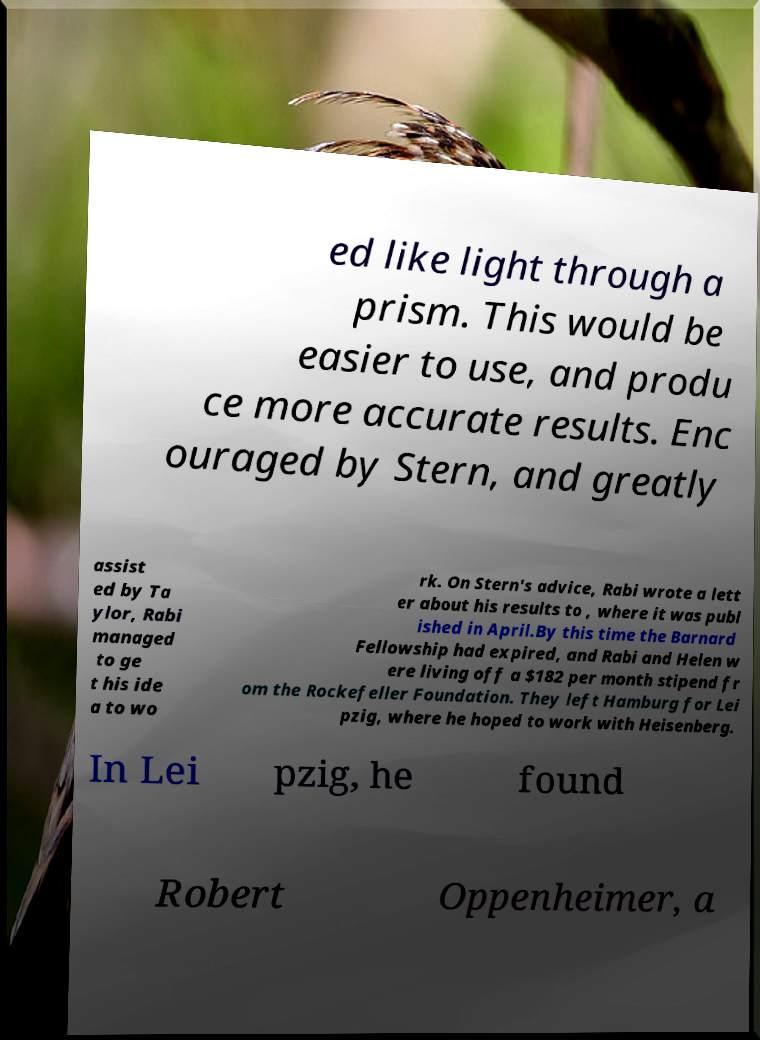Can you read and provide the text displayed in the image?This photo seems to have some interesting text. Can you extract and type it out for me? ed like light through a prism. This would be easier to use, and produ ce more accurate results. Enc ouraged by Stern, and greatly assist ed by Ta ylor, Rabi managed to ge t his ide a to wo rk. On Stern's advice, Rabi wrote a lett er about his results to , where it was publ ished in April.By this time the Barnard Fellowship had expired, and Rabi and Helen w ere living off a $182 per month stipend fr om the Rockefeller Foundation. They left Hamburg for Lei pzig, where he hoped to work with Heisenberg. In Lei pzig, he found Robert Oppenheimer, a 